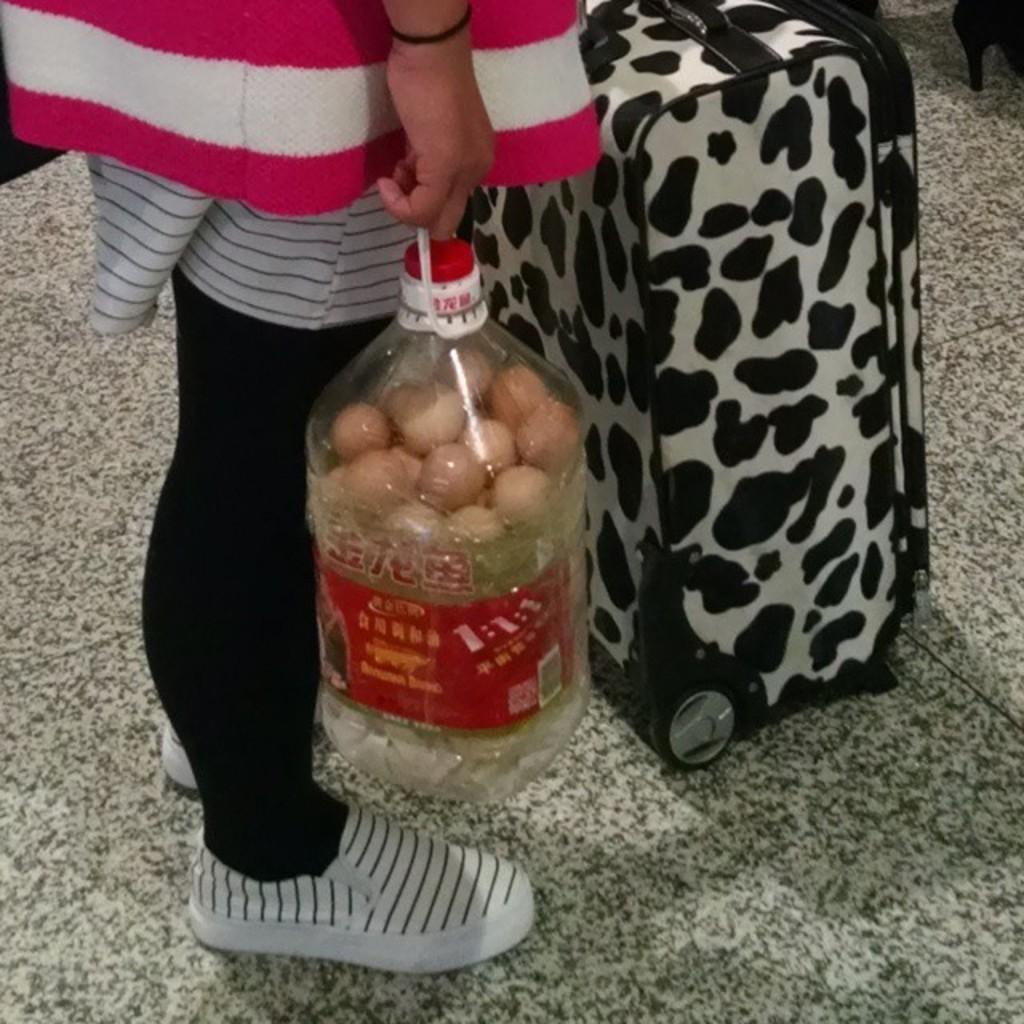Describe this image in one or two sentences. In this image i can see a woman standing and holding bottle at front there is a suitcase. 